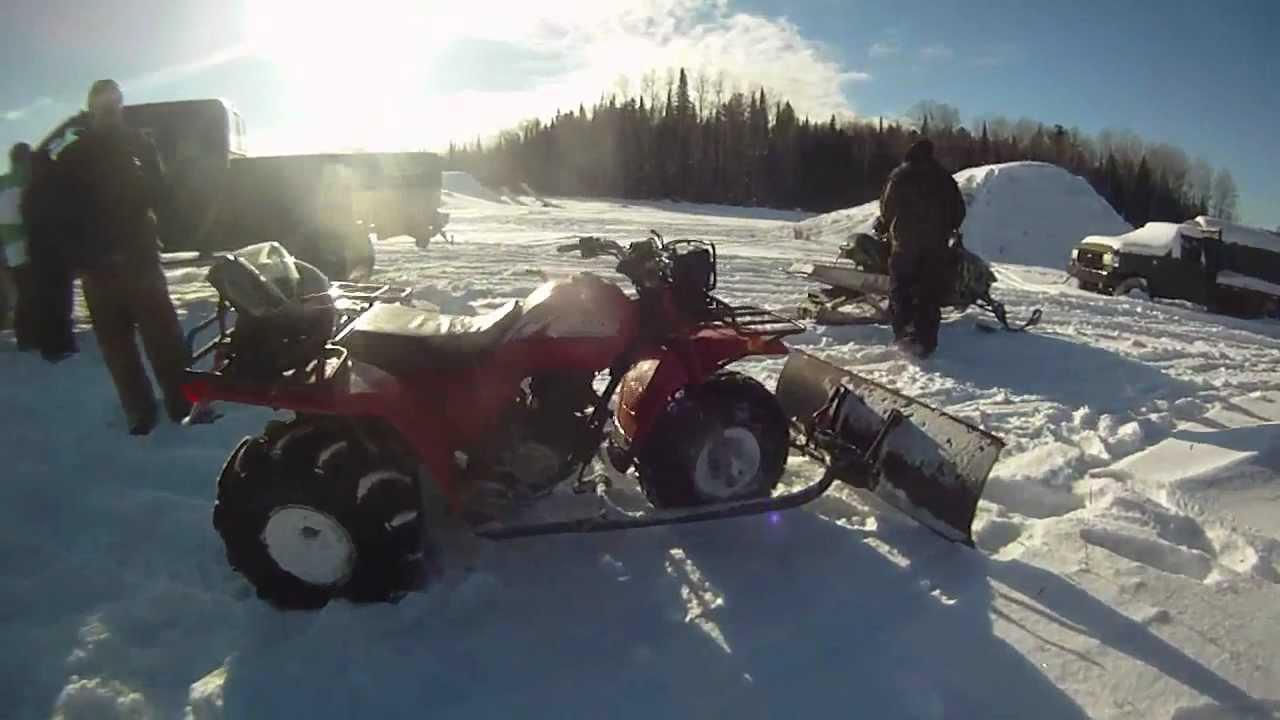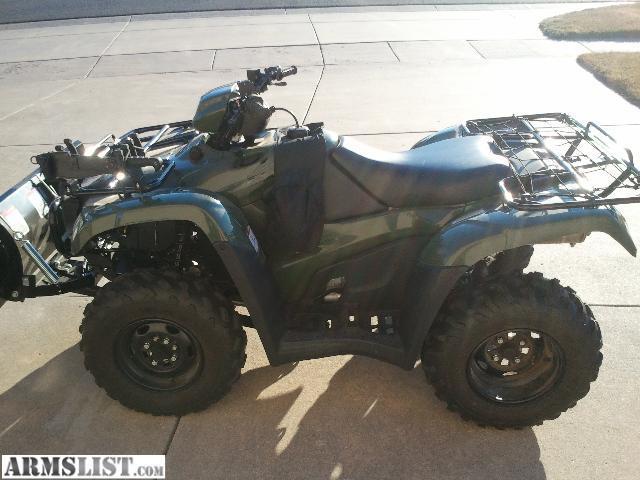The first image is the image on the left, the second image is the image on the right. Considering the images on both sides, is "There is at least one person in the image on the right." valid? Answer yes or no. No. 